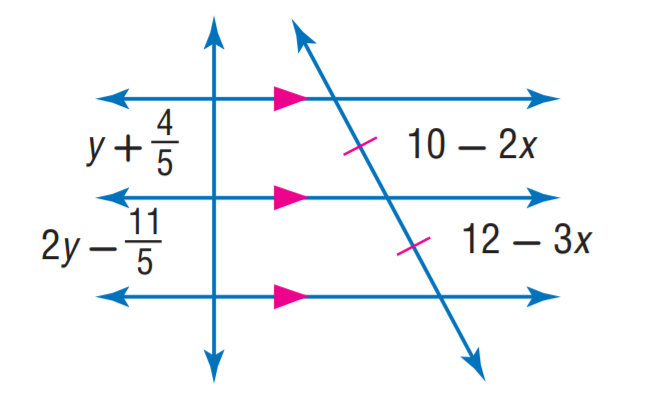Question: Find y.
Choices:
A. 1
B. 2
C. 3
D. 4
Answer with the letter. Answer: C Question: Find x.
Choices:
A. 1
B. 2
C. 3
D. 4
Answer with the letter. Answer: B 